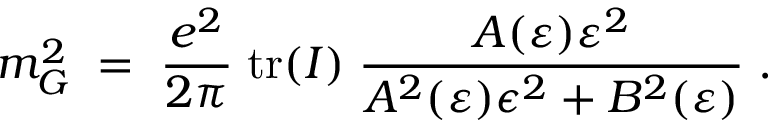Convert formula to latex. <formula><loc_0><loc_0><loc_500><loc_500>m _ { G } ^ { 2 } \, = \, \frac { e ^ { 2 } } { 2 \pi } \, t r ( I ) \, \frac { A ( \varepsilon ) \varepsilon ^ { 2 } } { A ^ { 2 } ( \varepsilon ) \epsilon ^ { 2 } + B ^ { 2 } ( \varepsilon ) } \, .</formula> 